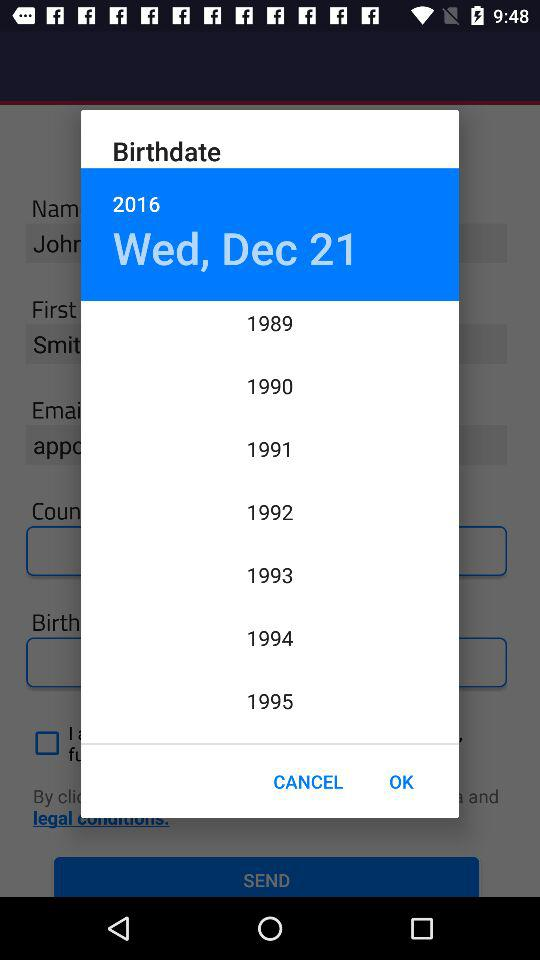What is the birthdate? The birthdate is Wednesday, December 21, 2016. 